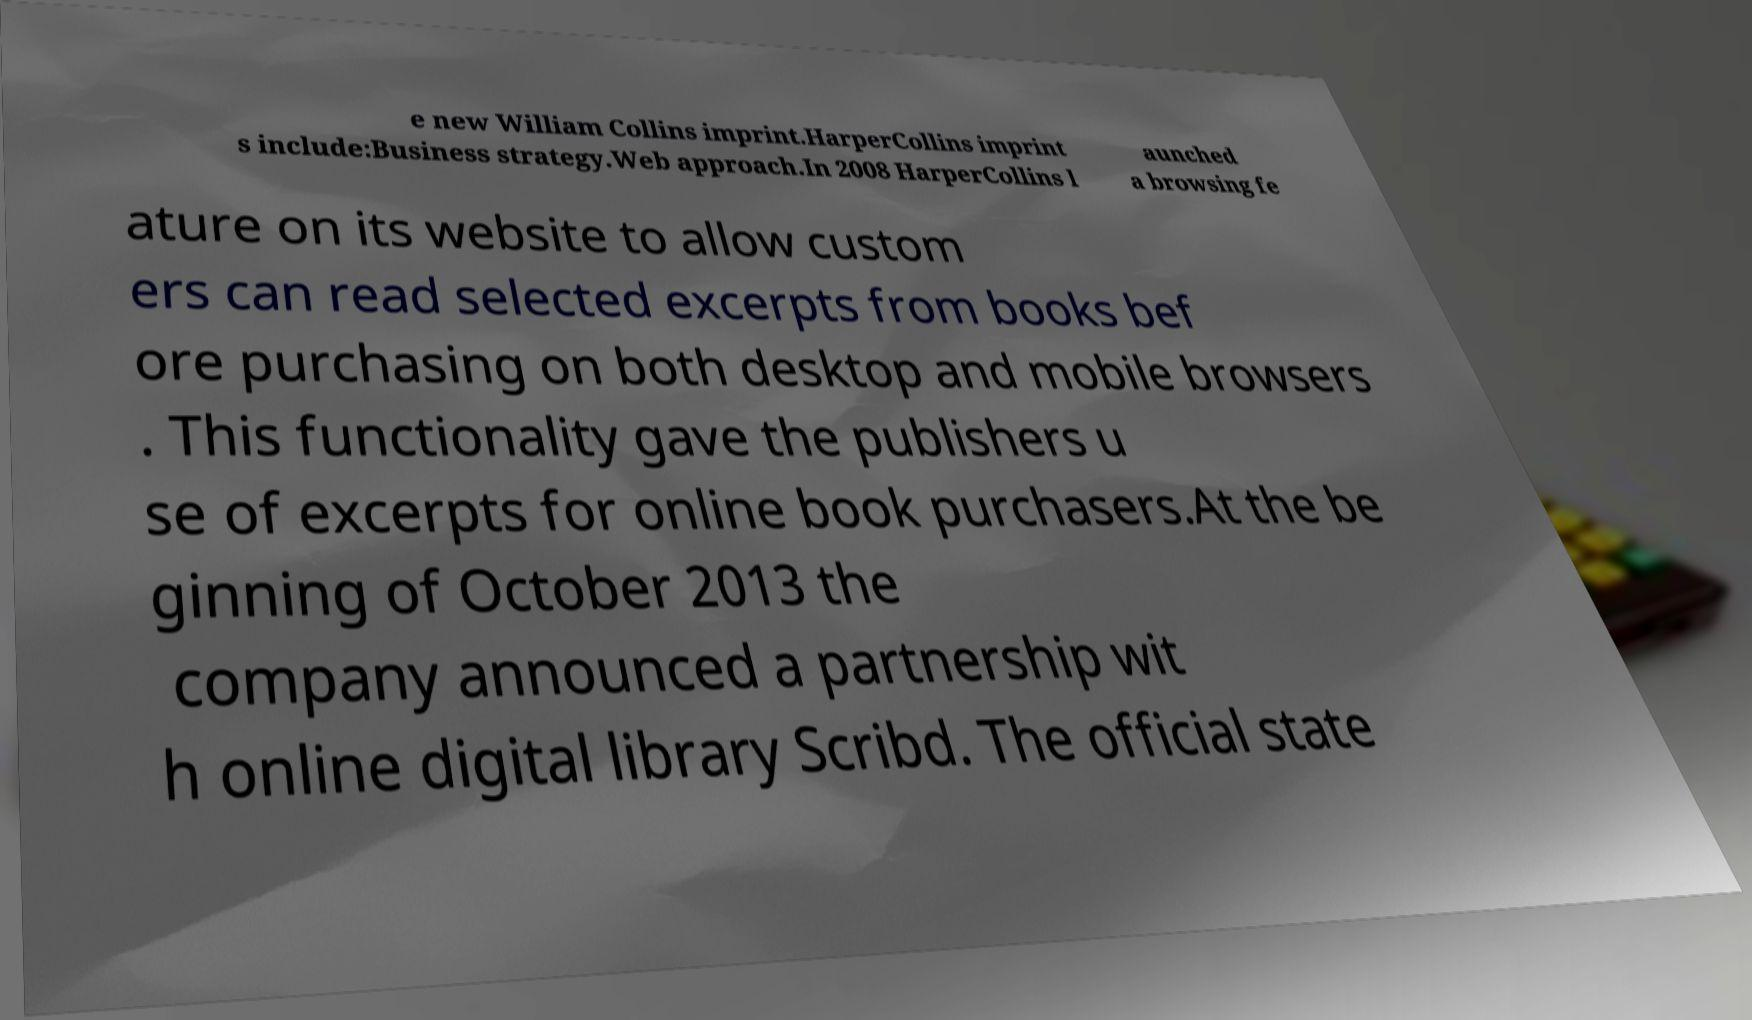Please read and relay the text visible in this image. What does it say? e new William Collins imprint.HarperCollins imprint s include:Business strategy.Web approach.In 2008 HarperCollins l aunched a browsing fe ature on its website to allow custom ers can read selected excerpts from books bef ore purchasing on both desktop and mobile browsers . This functionality gave the publishers u se of excerpts for online book purchasers.At the be ginning of October 2013 the company announced a partnership wit h online digital library Scribd. The official state 